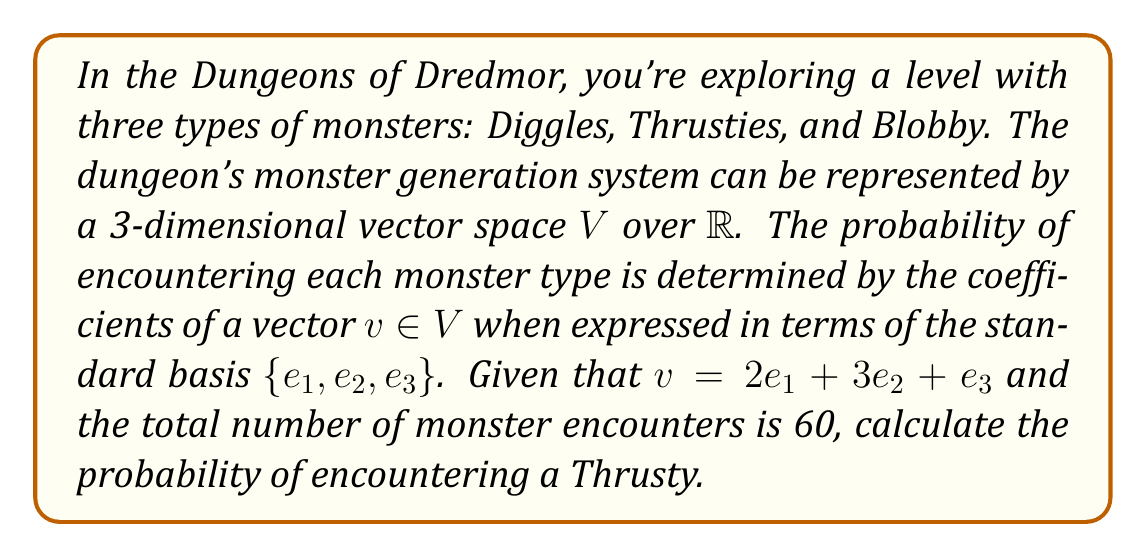Provide a solution to this math problem. Let's approach this step-by-step using concepts from representation theory:

1) The vector space $V$ represents the monster generation system, where:
   $e_1$ corresponds to Diggles
   $e_2$ corresponds to Thrusties
   $e_3$ corresponds to Blobby

2) The vector $v = 2e_1 + 3e_2 + e_3$ represents the relative frequencies of each monster type.

3) To find the probability, we need to normalize these frequencies:

   Total weight: $2 + 3 + 1 = 6$

4) The normalized vector is:
   $$v_{norm} = \frac{2}{6}e_1 + \frac{3}{6}e_2 + \frac{1}{6}e_3$$

5) These coefficients now represent the probabilities of encountering each monster type in a single encounter.

6) For Thrusties, corresponding to $e_2$, the probability is $\frac{3}{6} = \frac{1}{2}$.

7) Given that there are 60 total monster encounters, the expected number of Thrusty encounters is:
   $$60 \cdot \frac{1}{2} = 30$$

8) Therefore, the probability of encountering a Thrusty in this dungeon level is $\frac{30}{60} = \frac{1}{2}$.
Answer: $\frac{1}{2}$ 